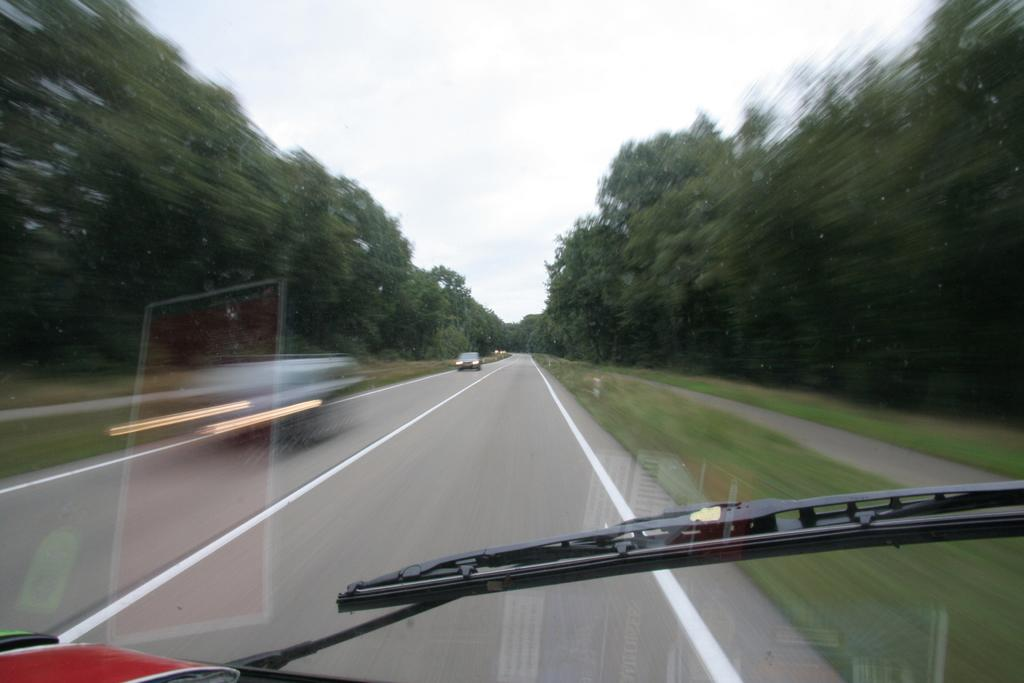What object can be seen in the image that is typically used to clear rain or snow from a vehicle's windshield? There is a windshield wiper in the image. What can be seen through the glass in the image? Vehicles on the road are visible through the glass. What type of vegetation is present in the image? Grass is present in the image. What other natural elements can be seen in the image? Trees are visible in the image. What is visible in the background of the image? The sky is visible in the background of the image. What type of birthday celebration is taking place in the image? There is no indication of a birthday celebration in the image. Can you see any blood in the image? There is no blood present in the image. 